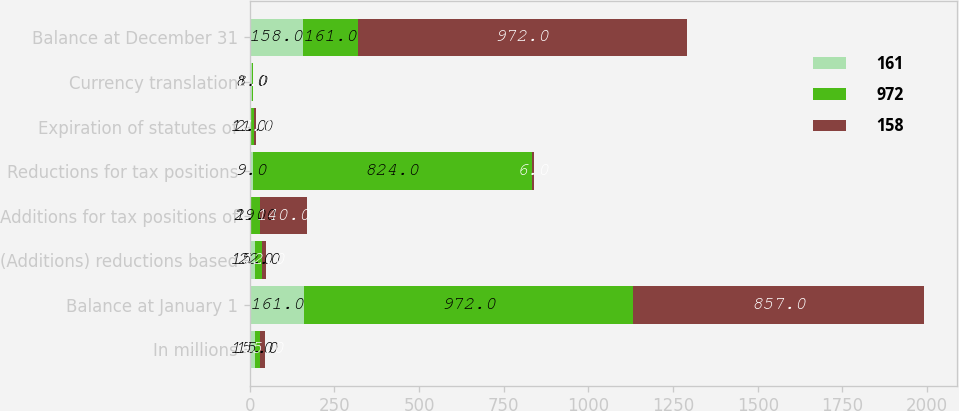<chart> <loc_0><loc_0><loc_500><loc_500><stacked_bar_chart><ecel><fcel>In millions<fcel>Balance at January 1<fcel>(Additions) reductions based<fcel>Additions for tax positions of<fcel>Reductions for tax positions<fcel>Expiration of statutes of<fcel>Currency translation<fcel>Balance at December 31<nl><fcel>161<fcel>15<fcel>161<fcel>15<fcel>1<fcel>9<fcel>2<fcel>8<fcel>158<nl><fcel>972<fcel>15<fcel>972<fcel>22<fcel>29<fcel>824<fcel>11<fcel>1<fcel>161<nl><fcel>158<fcel>15<fcel>857<fcel>12<fcel>140<fcel>6<fcel>7<fcel>2<fcel>972<nl></chart> 